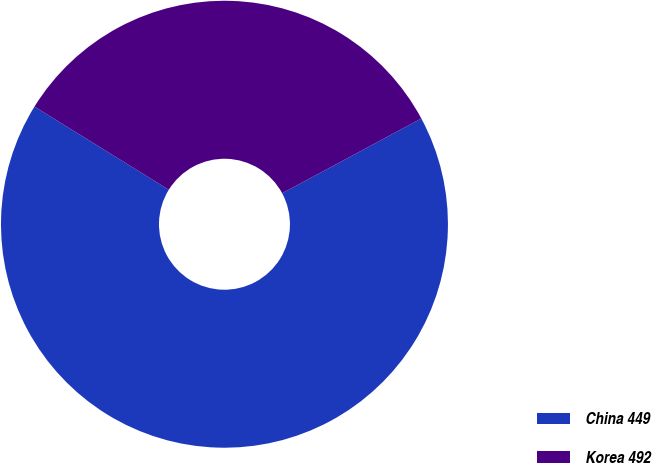Convert chart to OTSL. <chart><loc_0><loc_0><loc_500><loc_500><pie_chart><fcel>China 449<fcel>Korea 492<nl><fcel>66.67%<fcel>33.33%<nl></chart> 